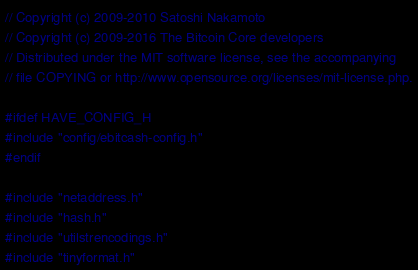Convert code to text. <code><loc_0><loc_0><loc_500><loc_500><_C++_>// Copyright (c) 2009-2010 Satoshi Nakamoto
// Copyright (c) 2009-2016 The Bitcoin Core developers
// Distributed under the MIT software license, see the accompanying
// file COPYING or http://www.opensource.org/licenses/mit-license.php.

#ifdef HAVE_CONFIG_H
#include "config/ebitcash-config.h"
#endif

#include "netaddress.h"
#include "hash.h"
#include "utilstrencodings.h"
#include "tinyformat.h"
</code> 